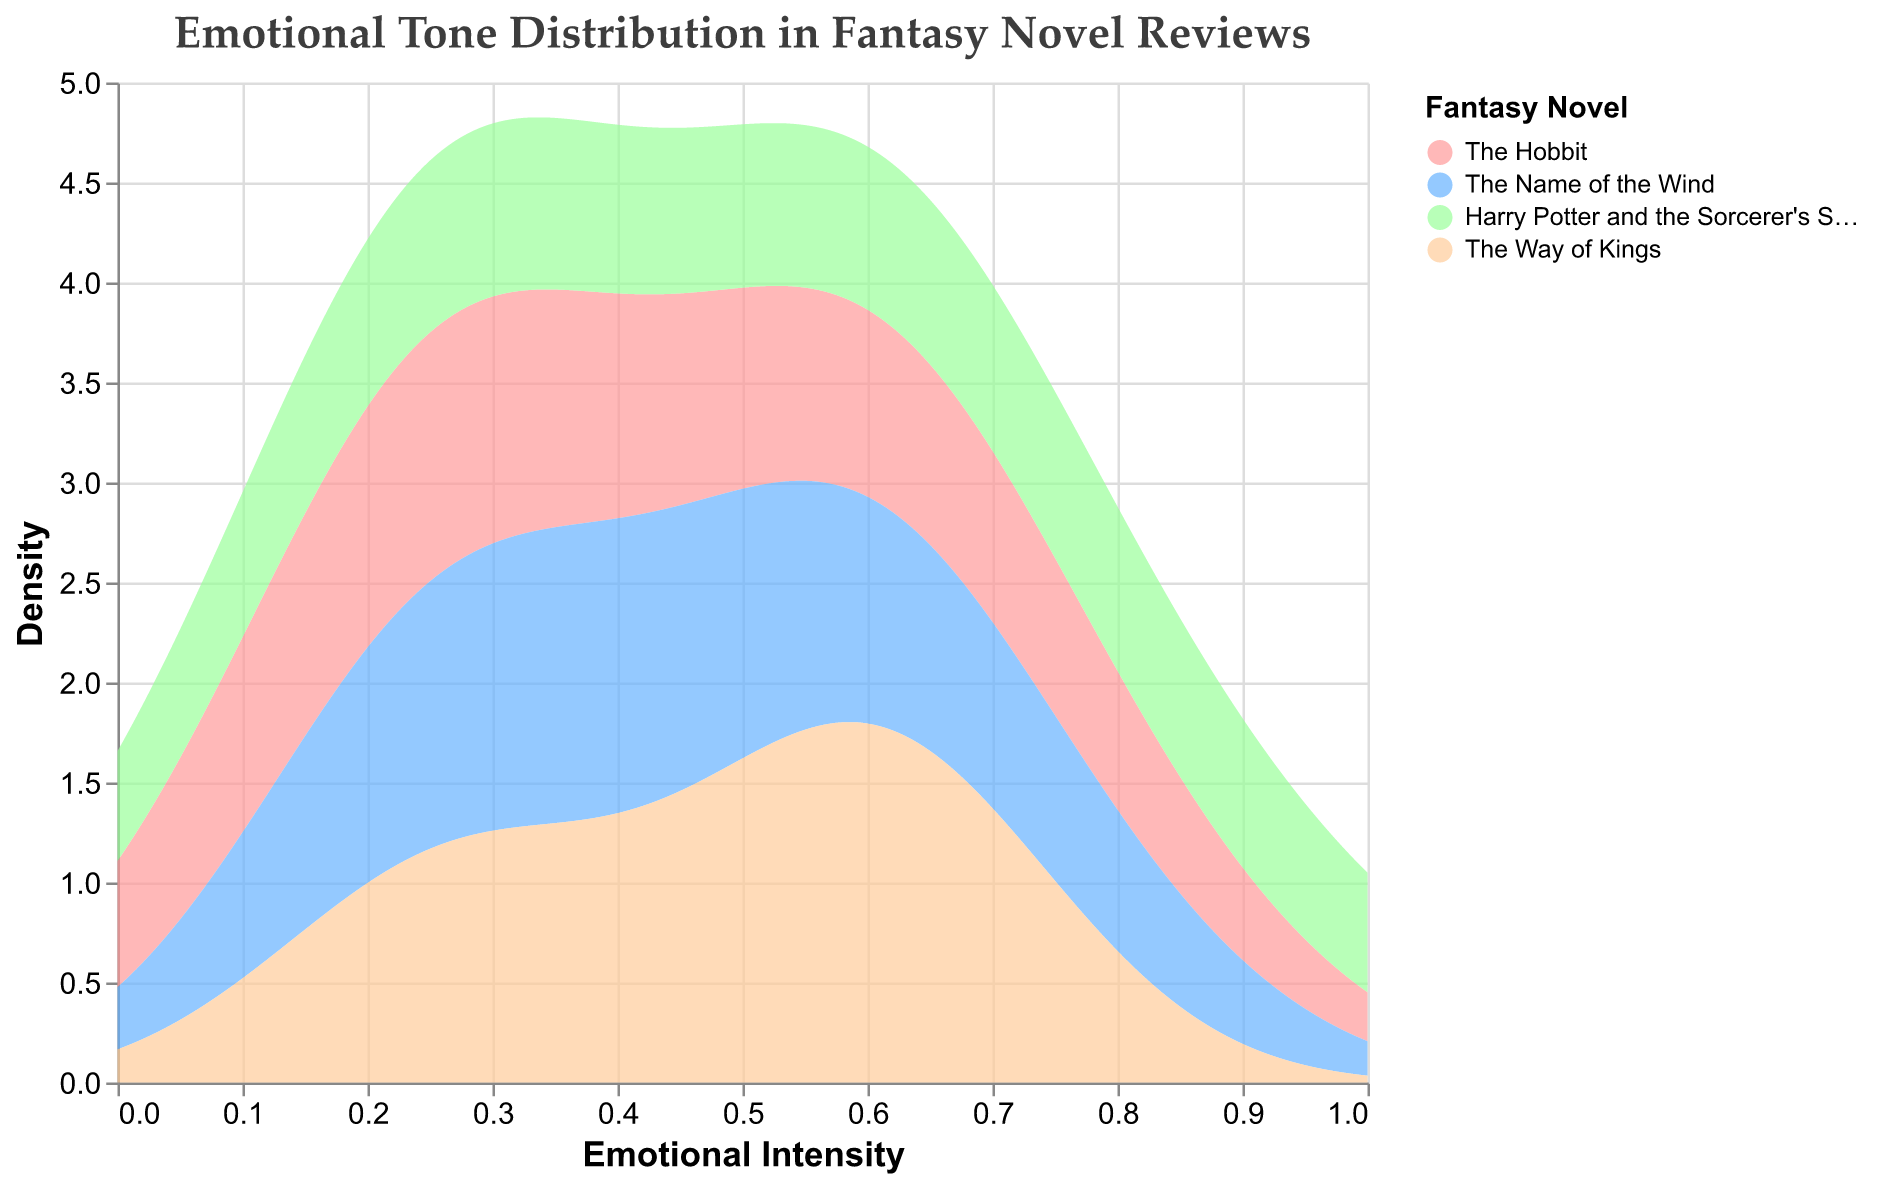Which fantasy novel has the highest density of high emotional intensity? To find this, look for the peak or highest region of the lines in the plot. "Harry Potter and the Sorcerer's Stone" has a peak density at the higher end of emotional intensity (around 0.9).
Answer: Harry Potter and the Sorcerer's Stone What's the title of the figure? The title is prominently displayed at the top of the figure, written in a large font size.
Answer: Emotional Tone Distribution in Fantasy Novel Reviews Which fantasy novel shows the widest range of emotional intensity? To determine the widest range, examine the spread of the densities along the x-axis for each novel. "Harry Potter and the Sorcerer's Stone" shows a wide range from low to high emotional intensity.
Answer: Harry Potter and the Sorcerer's Stone Compare the density of "Joy" for "The Hobbit" and "The Way of Kings" at an emotional intensity of 0.6. Which one is higher? Look at the density values of the different novels at 0.6 intensity. "The Hobbit" and "The Way of Kings" both have densities at this intensity. "The Way of Kings" has a slightly higher density at 0.6.
Answer: The Way of Kings What color represents "The Name of the Wind"? Check the color legend usually found on the right of the plot. "The Name of the Wind" is represented by a blue color.
Answer: Blue Does "The Hobbit" have any high-density regions for low emotional intensity? Examine the density line for "The Hobbit" on the left side of the x-axis (low emotional intensity). There is a notable peak around 0.1 intensity.
Answer: Yes Which emotion shows consistently lower density across all novels? Viewing the density lines across the entire plot, emotions such as "Disgust" and "Anger" have lower densities consistently across all novels.
Answer: Disgust/Anger What is the x-axis labeled as? The label for the x-axis is usually found at the bottom of the plot. In this case, it's labeled "Emotional Intensity".
Answer: Emotional Intensity What density value do you associate with peak "Trust" reviews for "Harry Potter and the Sorcerer's Stone"? Find the peak density point for "Harry Potter and the Sorcerer's Stone" representing "Trust". Peak "Trust" for this novel occurs at around 0.9 emotional intensity, with a high density.
Answer: Around 0.9 